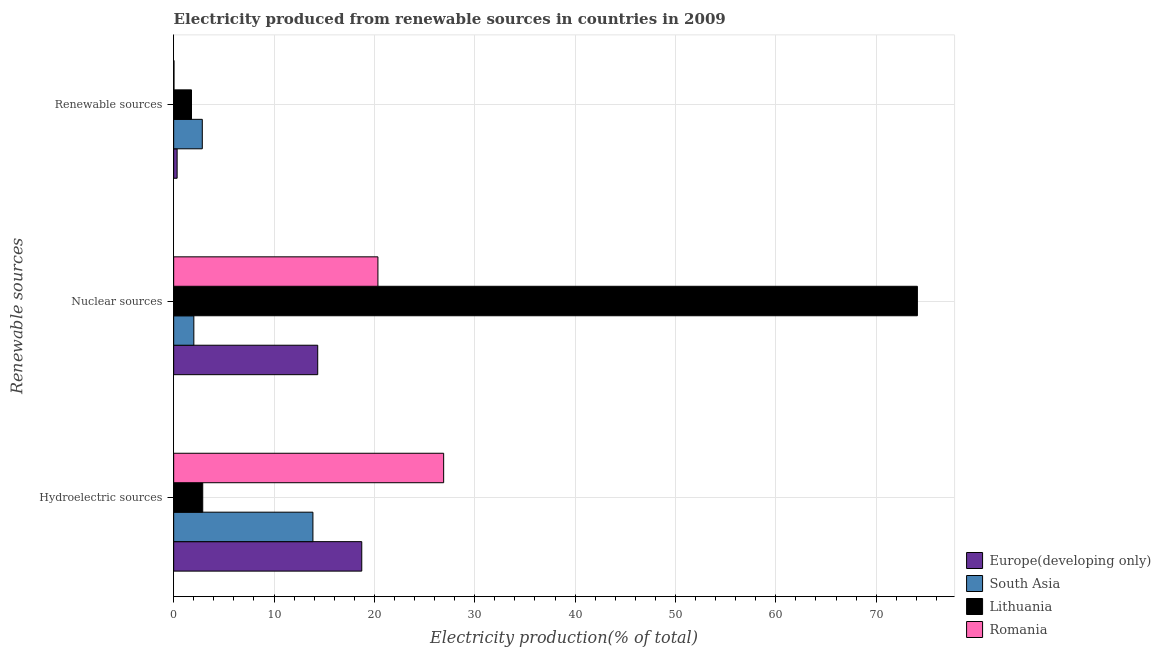How many different coloured bars are there?
Give a very brief answer. 4. Are the number of bars on each tick of the Y-axis equal?
Provide a short and direct response. Yes. What is the label of the 2nd group of bars from the top?
Give a very brief answer. Nuclear sources. What is the percentage of electricity produced by renewable sources in Romania?
Your answer should be compact. 0.03. Across all countries, what is the maximum percentage of electricity produced by nuclear sources?
Make the answer very short. 74.11. Across all countries, what is the minimum percentage of electricity produced by nuclear sources?
Make the answer very short. 2.01. In which country was the percentage of electricity produced by hydroelectric sources maximum?
Ensure brevity in your answer.  Romania. In which country was the percentage of electricity produced by hydroelectric sources minimum?
Provide a succinct answer. Lithuania. What is the total percentage of electricity produced by renewable sources in the graph?
Keep it short and to the point. 5.01. What is the difference between the percentage of electricity produced by renewable sources in South Asia and that in Lithuania?
Provide a succinct answer. 1.08. What is the difference between the percentage of electricity produced by nuclear sources in South Asia and the percentage of electricity produced by hydroelectric sources in Lithuania?
Provide a short and direct response. -0.89. What is the average percentage of electricity produced by nuclear sources per country?
Your response must be concise. 27.71. What is the difference between the percentage of electricity produced by nuclear sources and percentage of electricity produced by hydroelectric sources in Lithuania?
Give a very brief answer. 71.21. In how many countries, is the percentage of electricity produced by hydroelectric sources greater than 50 %?
Offer a terse response. 0. What is the ratio of the percentage of electricity produced by renewable sources in South Asia to that in Romania?
Ensure brevity in your answer.  86.7. Is the percentage of electricity produced by hydroelectric sources in South Asia less than that in Romania?
Your answer should be compact. Yes. What is the difference between the highest and the second highest percentage of electricity produced by hydroelectric sources?
Your response must be concise. 8.16. What is the difference between the highest and the lowest percentage of electricity produced by hydroelectric sources?
Give a very brief answer. 24.01. What does the 1st bar from the top in Hydroelectric sources represents?
Make the answer very short. Romania. Is it the case that in every country, the sum of the percentage of electricity produced by hydroelectric sources and percentage of electricity produced by nuclear sources is greater than the percentage of electricity produced by renewable sources?
Provide a succinct answer. Yes. How many bars are there?
Provide a short and direct response. 12. Are all the bars in the graph horizontal?
Offer a very short reply. Yes. How many countries are there in the graph?
Your answer should be compact. 4. Does the graph contain grids?
Your response must be concise. Yes. How many legend labels are there?
Give a very brief answer. 4. What is the title of the graph?
Provide a succinct answer. Electricity produced from renewable sources in countries in 2009. Does "Armenia" appear as one of the legend labels in the graph?
Your answer should be compact. No. What is the label or title of the X-axis?
Give a very brief answer. Electricity production(% of total). What is the label or title of the Y-axis?
Offer a terse response. Renewable sources. What is the Electricity production(% of total) in Europe(developing only) in Hydroelectric sources?
Ensure brevity in your answer.  18.74. What is the Electricity production(% of total) in South Asia in Hydroelectric sources?
Offer a terse response. 13.88. What is the Electricity production(% of total) of Lithuania in Hydroelectric sources?
Ensure brevity in your answer.  2.9. What is the Electricity production(% of total) of Romania in Hydroelectric sources?
Provide a succinct answer. 26.9. What is the Electricity production(% of total) in Europe(developing only) in Nuclear sources?
Your answer should be very brief. 14.35. What is the Electricity production(% of total) of South Asia in Nuclear sources?
Your answer should be compact. 2.01. What is the Electricity production(% of total) in Lithuania in Nuclear sources?
Provide a succinct answer. 74.11. What is the Electricity production(% of total) of Romania in Nuclear sources?
Make the answer very short. 20.35. What is the Electricity production(% of total) in Europe(developing only) in Renewable sources?
Make the answer very short. 0.34. What is the Electricity production(% of total) in South Asia in Renewable sources?
Your answer should be compact. 2.85. What is the Electricity production(% of total) in Lithuania in Renewable sources?
Provide a succinct answer. 1.78. What is the Electricity production(% of total) in Romania in Renewable sources?
Your response must be concise. 0.03. Across all Renewable sources, what is the maximum Electricity production(% of total) of Europe(developing only)?
Your response must be concise. 18.74. Across all Renewable sources, what is the maximum Electricity production(% of total) in South Asia?
Make the answer very short. 13.88. Across all Renewable sources, what is the maximum Electricity production(% of total) in Lithuania?
Offer a terse response. 74.11. Across all Renewable sources, what is the maximum Electricity production(% of total) of Romania?
Provide a succinct answer. 26.9. Across all Renewable sources, what is the minimum Electricity production(% of total) in Europe(developing only)?
Make the answer very short. 0.34. Across all Renewable sources, what is the minimum Electricity production(% of total) of South Asia?
Give a very brief answer. 2.01. Across all Renewable sources, what is the minimum Electricity production(% of total) of Lithuania?
Provide a short and direct response. 1.78. Across all Renewable sources, what is the minimum Electricity production(% of total) of Romania?
Your answer should be compact. 0.03. What is the total Electricity production(% of total) of Europe(developing only) in the graph?
Offer a very short reply. 33.44. What is the total Electricity production(% of total) of South Asia in the graph?
Provide a short and direct response. 18.74. What is the total Electricity production(% of total) in Lithuania in the graph?
Make the answer very short. 78.78. What is the total Electricity production(% of total) of Romania in the graph?
Your response must be concise. 47.29. What is the difference between the Electricity production(% of total) of Europe(developing only) in Hydroelectric sources and that in Nuclear sources?
Your response must be concise. 4.39. What is the difference between the Electricity production(% of total) in South Asia in Hydroelectric sources and that in Nuclear sources?
Your response must be concise. 11.87. What is the difference between the Electricity production(% of total) of Lithuania in Hydroelectric sources and that in Nuclear sources?
Offer a terse response. -71.21. What is the difference between the Electricity production(% of total) in Romania in Hydroelectric sources and that in Nuclear sources?
Your response must be concise. 6.55. What is the difference between the Electricity production(% of total) in Europe(developing only) in Hydroelectric sources and that in Renewable sources?
Provide a short and direct response. 18.4. What is the difference between the Electricity production(% of total) of South Asia in Hydroelectric sources and that in Renewable sources?
Make the answer very short. 11.02. What is the difference between the Electricity production(% of total) of Lithuania in Hydroelectric sources and that in Renewable sources?
Your answer should be very brief. 1.12. What is the difference between the Electricity production(% of total) of Romania in Hydroelectric sources and that in Renewable sources?
Provide a succinct answer. 26.87. What is the difference between the Electricity production(% of total) in Europe(developing only) in Nuclear sources and that in Renewable sources?
Your answer should be very brief. 14.01. What is the difference between the Electricity production(% of total) of South Asia in Nuclear sources and that in Renewable sources?
Give a very brief answer. -0.84. What is the difference between the Electricity production(% of total) in Lithuania in Nuclear sources and that in Renewable sources?
Make the answer very short. 72.33. What is the difference between the Electricity production(% of total) in Romania in Nuclear sources and that in Renewable sources?
Ensure brevity in your answer.  20.32. What is the difference between the Electricity production(% of total) in Europe(developing only) in Hydroelectric sources and the Electricity production(% of total) in South Asia in Nuclear sources?
Provide a succinct answer. 16.73. What is the difference between the Electricity production(% of total) in Europe(developing only) in Hydroelectric sources and the Electricity production(% of total) in Lithuania in Nuclear sources?
Make the answer very short. -55.37. What is the difference between the Electricity production(% of total) of Europe(developing only) in Hydroelectric sources and the Electricity production(% of total) of Romania in Nuclear sources?
Your answer should be very brief. -1.61. What is the difference between the Electricity production(% of total) in South Asia in Hydroelectric sources and the Electricity production(% of total) in Lithuania in Nuclear sources?
Your answer should be compact. -60.23. What is the difference between the Electricity production(% of total) of South Asia in Hydroelectric sources and the Electricity production(% of total) of Romania in Nuclear sources?
Keep it short and to the point. -6.48. What is the difference between the Electricity production(% of total) in Lithuania in Hydroelectric sources and the Electricity production(% of total) in Romania in Nuclear sources?
Your response must be concise. -17.46. What is the difference between the Electricity production(% of total) of Europe(developing only) in Hydroelectric sources and the Electricity production(% of total) of South Asia in Renewable sources?
Keep it short and to the point. 15.89. What is the difference between the Electricity production(% of total) of Europe(developing only) in Hydroelectric sources and the Electricity production(% of total) of Lithuania in Renewable sources?
Offer a very short reply. 16.97. What is the difference between the Electricity production(% of total) in Europe(developing only) in Hydroelectric sources and the Electricity production(% of total) in Romania in Renewable sources?
Your answer should be very brief. 18.71. What is the difference between the Electricity production(% of total) of South Asia in Hydroelectric sources and the Electricity production(% of total) of Lithuania in Renewable sources?
Your answer should be very brief. 12.1. What is the difference between the Electricity production(% of total) in South Asia in Hydroelectric sources and the Electricity production(% of total) in Romania in Renewable sources?
Your answer should be compact. 13.84. What is the difference between the Electricity production(% of total) of Lithuania in Hydroelectric sources and the Electricity production(% of total) of Romania in Renewable sources?
Make the answer very short. 2.86. What is the difference between the Electricity production(% of total) in Europe(developing only) in Nuclear sources and the Electricity production(% of total) in South Asia in Renewable sources?
Give a very brief answer. 11.5. What is the difference between the Electricity production(% of total) in Europe(developing only) in Nuclear sources and the Electricity production(% of total) in Lithuania in Renewable sources?
Your answer should be very brief. 12.58. What is the difference between the Electricity production(% of total) of Europe(developing only) in Nuclear sources and the Electricity production(% of total) of Romania in Renewable sources?
Provide a succinct answer. 14.32. What is the difference between the Electricity production(% of total) in South Asia in Nuclear sources and the Electricity production(% of total) in Lithuania in Renewable sources?
Offer a very short reply. 0.23. What is the difference between the Electricity production(% of total) in South Asia in Nuclear sources and the Electricity production(% of total) in Romania in Renewable sources?
Your answer should be very brief. 1.98. What is the difference between the Electricity production(% of total) of Lithuania in Nuclear sources and the Electricity production(% of total) of Romania in Renewable sources?
Make the answer very short. 74.08. What is the average Electricity production(% of total) of Europe(developing only) per Renewable sources?
Offer a terse response. 11.15. What is the average Electricity production(% of total) in South Asia per Renewable sources?
Your response must be concise. 6.25. What is the average Electricity production(% of total) in Lithuania per Renewable sources?
Keep it short and to the point. 26.26. What is the average Electricity production(% of total) in Romania per Renewable sources?
Your response must be concise. 15.76. What is the difference between the Electricity production(% of total) in Europe(developing only) and Electricity production(% of total) in South Asia in Hydroelectric sources?
Your answer should be very brief. 4.87. What is the difference between the Electricity production(% of total) in Europe(developing only) and Electricity production(% of total) in Lithuania in Hydroelectric sources?
Ensure brevity in your answer.  15.85. What is the difference between the Electricity production(% of total) in Europe(developing only) and Electricity production(% of total) in Romania in Hydroelectric sources?
Your answer should be very brief. -8.16. What is the difference between the Electricity production(% of total) in South Asia and Electricity production(% of total) in Lithuania in Hydroelectric sources?
Make the answer very short. 10.98. What is the difference between the Electricity production(% of total) of South Asia and Electricity production(% of total) of Romania in Hydroelectric sources?
Offer a very short reply. -13.03. What is the difference between the Electricity production(% of total) in Lithuania and Electricity production(% of total) in Romania in Hydroelectric sources?
Give a very brief answer. -24.01. What is the difference between the Electricity production(% of total) in Europe(developing only) and Electricity production(% of total) in South Asia in Nuclear sources?
Keep it short and to the point. 12.34. What is the difference between the Electricity production(% of total) of Europe(developing only) and Electricity production(% of total) of Lithuania in Nuclear sources?
Keep it short and to the point. -59.76. What is the difference between the Electricity production(% of total) in Europe(developing only) and Electricity production(% of total) in Romania in Nuclear sources?
Make the answer very short. -6. What is the difference between the Electricity production(% of total) in South Asia and Electricity production(% of total) in Lithuania in Nuclear sources?
Ensure brevity in your answer.  -72.1. What is the difference between the Electricity production(% of total) in South Asia and Electricity production(% of total) in Romania in Nuclear sources?
Offer a very short reply. -18.34. What is the difference between the Electricity production(% of total) of Lithuania and Electricity production(% of total) of Romania in Nuclear sources?
Your answer should be compact. 53.76. What is the difference between the Electricity production(% of total) in Europe(developing only) and Electricity production(% of total) in South Asia in Renewable sources?
Offer a very short reply. -2.51. What is the difference between the Electricity production(% of total) in Europe(developing only) and Electricity production(% of total) in Lithuania in Renewable sources?
Ensure brevity in your answer.  -1.43. What is the difference between the Electricity production(% of total) of Europe(developing only) and Electricity production(% of total) of Romania in Renewable sources?
Your answer should be compact. 0.31. What is the difference between the Electricity production(% of total) of South Asia and Electricity production(% of total) of Lithuania in Renewable sources?
Offer a terse response. 1.08. What is the difference between the Electricity production(% of total) of South Asia and Electricity production(% of total) of Romania in Renewable sources?
Your response must be concise. 2.82. What is the difference between the Electricity production(% of total) in Lithuania and Electricity production(% of total) in Romania in Renewable sources?
Your answer should be very brief. 1.74. What is the ratio of the Electricity production(% of total) of Europe(developing only) in Hydroelectric sources to that in Nuclear sources?
Keep it short and to the point. 1.31. What is the ratio of the Electricity production(% of total) of South Asia in Hydroelectric sources to that in Nuclear sources?
Keep it short and to the point. 6.9. What is the ratio of the Electricity production(% of total) in Lithuania in Hydroelectric sources to that in Nuclear sources?
Offer a very short reply. 0.04. What is the ratio of the Electricity production(% of total) in Romania in Hydroelectric sources to that in Nuclear sources?
Ensure brevity in your answer.  1.32. What is the ratio of the Electricity production(% of total) of Europe(developing only) in Hydroelectric sources to that in Renewable sources?
Give a very brief answer. 54.39. What is the ratio of the Electricity production(% of total) of South Asia in Hydroelectric sources to that in Renewable sources?
Ensure brevity in your answer.  4.86. What is the ratio of the Electricity production(% of total) of Lithuania in Hydroelectric sources to that in Renewable sources?
Offer a terse response. 1.63. What is the ratio of the Electricity production(% of total) in Romania in Hydroelectric sources to that in Renewable sources?
Offer a terse response. 817.58. What is the ratio of the Electricity production(% of total) in Europe(developing only) in Nuclear sources to that in Renewable sources?
Offer a very short reply. 41.65. What is the ratio of the Electricity production(% of total) in South Asia in Nuclear sources to that in Renewable sources?
Make the answer very short. 0.7. What is the ratio of the Electricity production(% of total) in Lithuania in Nuclear sources to that in Renewable sources?
Offer a very short reply. 41.74. What is the ratio of the Electricity production(% of total) of Romania in Nuclear sources to that in Renewable sources?
Provide a succinct answer. 618.53. What is the difference between the highest and the second highest Electricity production(% of total) in Europe(developing only)?
Provide a short and direct response. 4.39. What is the difference between the highest and the second highest Electricity production(% of total) of South Asia?
Keep it short and to the point. 11.02. What is the difference between the highest and the second highest Electricity production(% of total) of Lithuania?
Offer a very short reply. 71.21. What is the difference between the highest and the second highest Electricity production(% of total) of Romania?
Offer a very short reply. 6.55. What is the difference between the highest and the lowest Electricity production(% of total) of Europe(developing only)?
Your response must be concise. 18.4. What is the difference between the highest and the lowest Electricity production(% of total) in South Asia?
Your response must be concise. 11.87. What is the difference between the highest and the lowest Electricity production(% of total) of Lithuania?
Your answer should be very brief. 72.33. What is the difference between the highest and the lowest Electricity production(% of total) in Romania?
Make the answer very short. 26.87. 